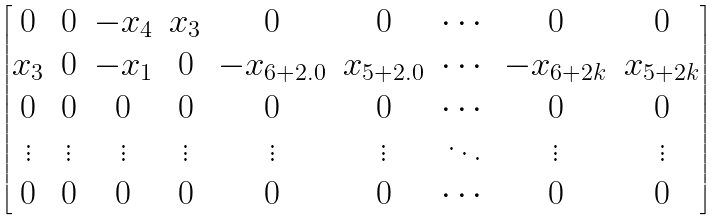<formula> <loc_0><loc_0><loc_500><loc_500>\begin{bmatrix} 0 & 0 & - x _ { 4 } & x _ { 3 } & 0 & 0 & \cdots & 0 & 0 \\ x _ { 3 } & 0 & - x _ { 1 } & 0 & - x _ { 6 + 2 . 0 } & x _ { 5 + 2 . 0 } & \cdots & - x _ { 6 + 2 k } & x _ { 5 + 2 k } \\ 0 & 0 & 0 & 0 & 0 & 0 & \cdots & 0 & 0 \\ \vdots & \vdots & \vdots & \vdots & \vdots & \vdots & \ddots & \vdots & \vdots \\ 0 & 0 & 0 & 0 & 0 & 0 & \cdots & 0 & 0 \end{bmatrix}</formula> 